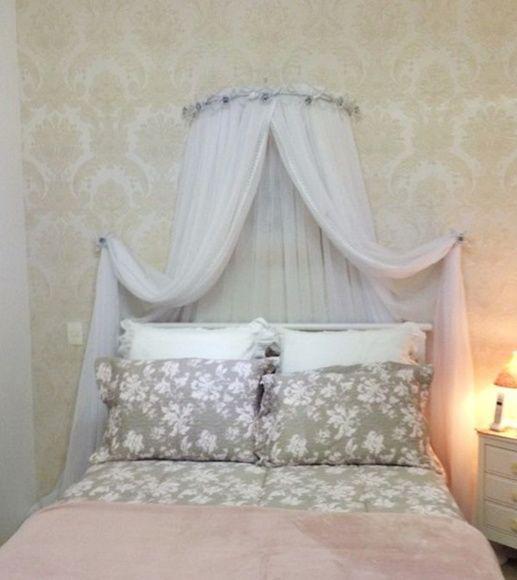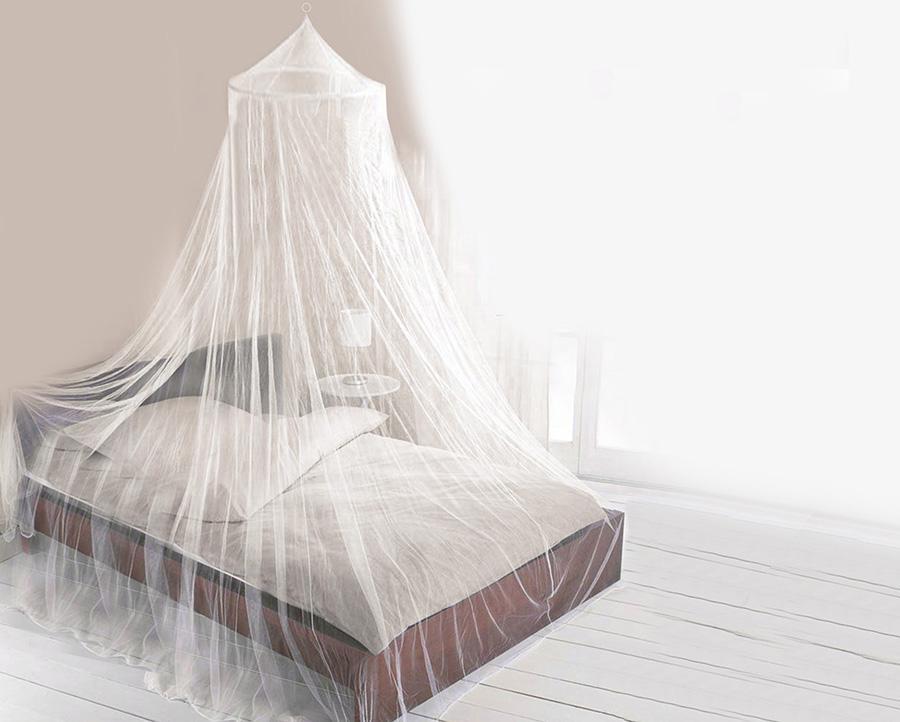The first image is the image on the left, the second image is the image on the right. Considering the images on both sides, is "One of the images of mosquito nets has a round top with silver flowers on it." valid? Answer yes or no. Yes. The first image is the image on the left, the second image is the image on the right. Evaluate the accuracy of this statement regarding the images: "The style and shape of bed netting is the same in both images.". Is it true? Answer yes or no. No. 